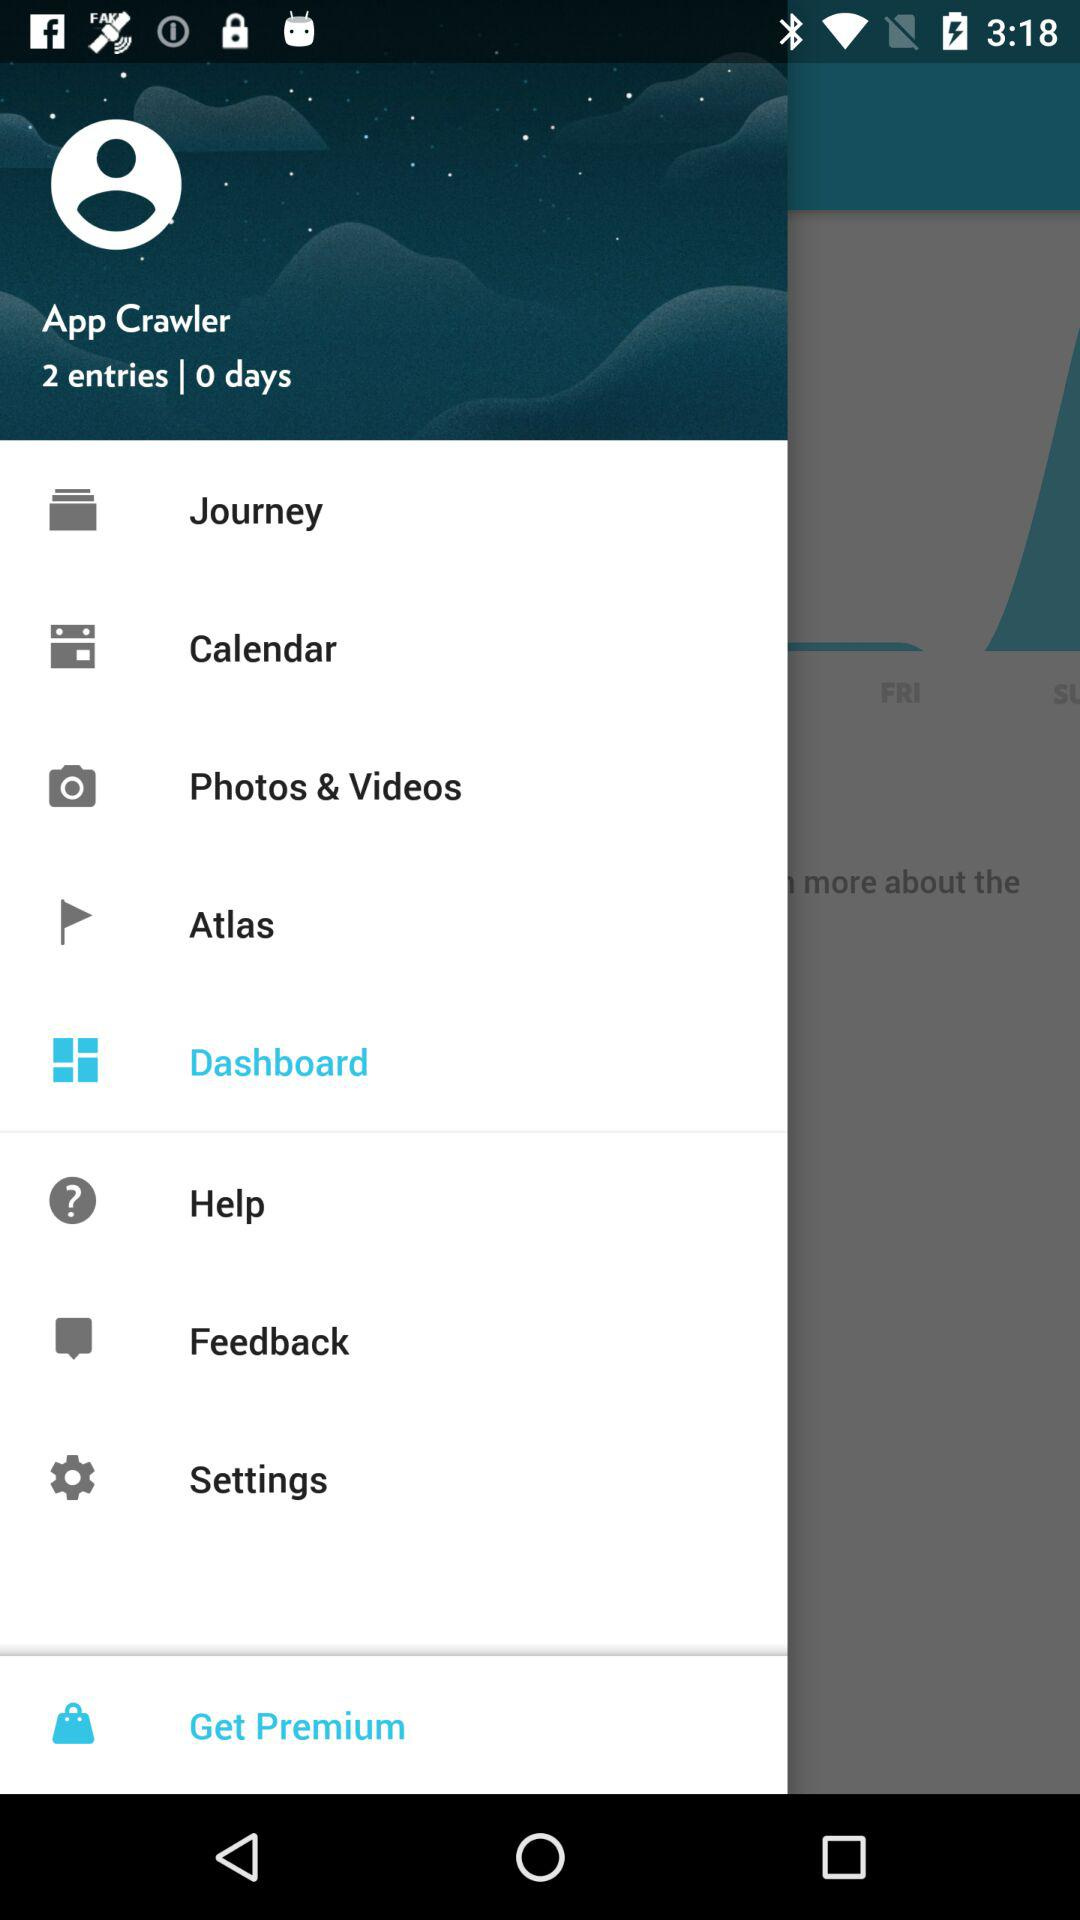What is the login name? The login name is App Crawler. 